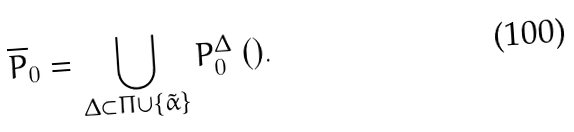<formula> <loc_0><loc_0><loc_500><loc_500>\overline { P } _ { 0 } = \bigcup _ { \Delta \subset \Pi \cup \{ \tilde { \alpha } \} } P _ { 0 } ^ { \Delta } \ ( ) .</formula> 